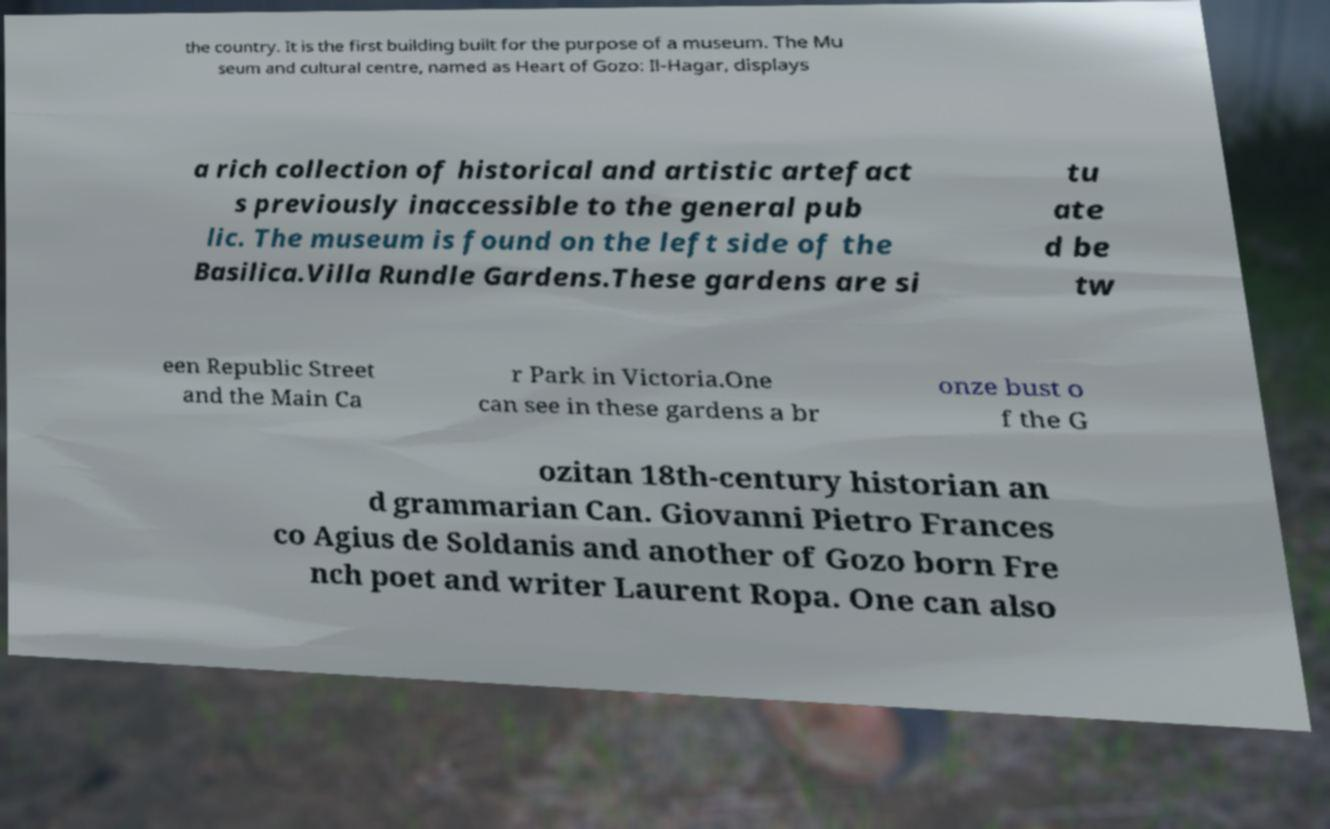Please identify and transcribe the text found in this image. the country. It is the first building built for the purpose of a museum. The Mu seum and cultural centre, named as Heart of Gozo: Il-Hagar, displays a rich collection of historical and artistic artefact s previously inaccessible to the general pub lic. The museum is found on the left side of the Basilica.Villa Rundle Gardens.These gardens are si tu ate d be tw een Republic Street and the Main Ca r Park in Victoria.One can see in these gardens a br onze bust o f the G ozitan 18th-century historian an d grammarian Can. Giovanni Pietro Frances co Agius de Soldanis and another of Gozo born Fre nch poet and writer Laurent Ropa. One can also 